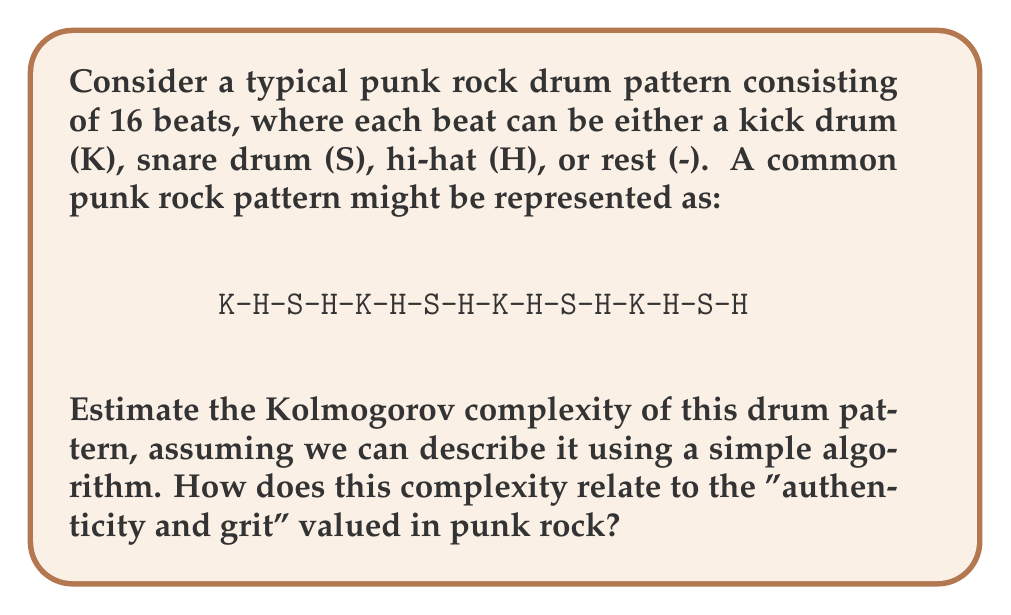Can you solve this math problem? To analyze the Kolmogorov complexity of this punk rock drum pattern, we need to consider the shortest possible program that could generate this sequence. Let's break it down step-by-step:

1. Observe the pattern: The 16-beat sequence repeats a 4-beat sub-pattern four times.

2. The 4-beat sub-pattern is: K-H-S-H

3. We can describe this pattern with a simple algorithm:
   - Define the sub-pattern: K-H-S-H
   - Repeat the sub-pattern 4 times

4. To formalize this in pseudocode:

   ```
   subpattern = "K-H-S-H"
   full_pattern = repeat(subpattern, 4)
   ```

5. The Kolmogorov complexity is approximately the length of this program in bits. Let's estimate:
   - Defining the subpattern: ~32 bits (4 characters * 8 bits per character)
   - Instruction to repeat: ~8 bits
   - Number of repetitions: ~3 bits (to represent 4)

6. Total estimated Kolmogorov complexity: 32 + 8 + 3 = 43 bits

This relatively low complexity indicates that the pattern is quite simple and repetitive. In the context of punk rock, which values authenticity and grit, this simplicity can be seen as:

a) Authentic: The straightforward, repetitive nature of the pattern aligns with punk's DIY ethos and rejection of complexity.

b) Gritty: The consistent, driving rhythm created by this simple pattern contributes to the raw energy associated with punk rock.

c) Accessible: The low complexity makes the pattern easy to play and remember, fitting punk's emphasis on participation over technical prowess.

However, it's worth noting that true authenticity in punk might involve occasional deviations from this strict pattern, which would increase its Kolmogorov complexity.
Answer: The estimated Kolmogorov complexity of the given punk rock drum pattern is approximately 43 bits. 